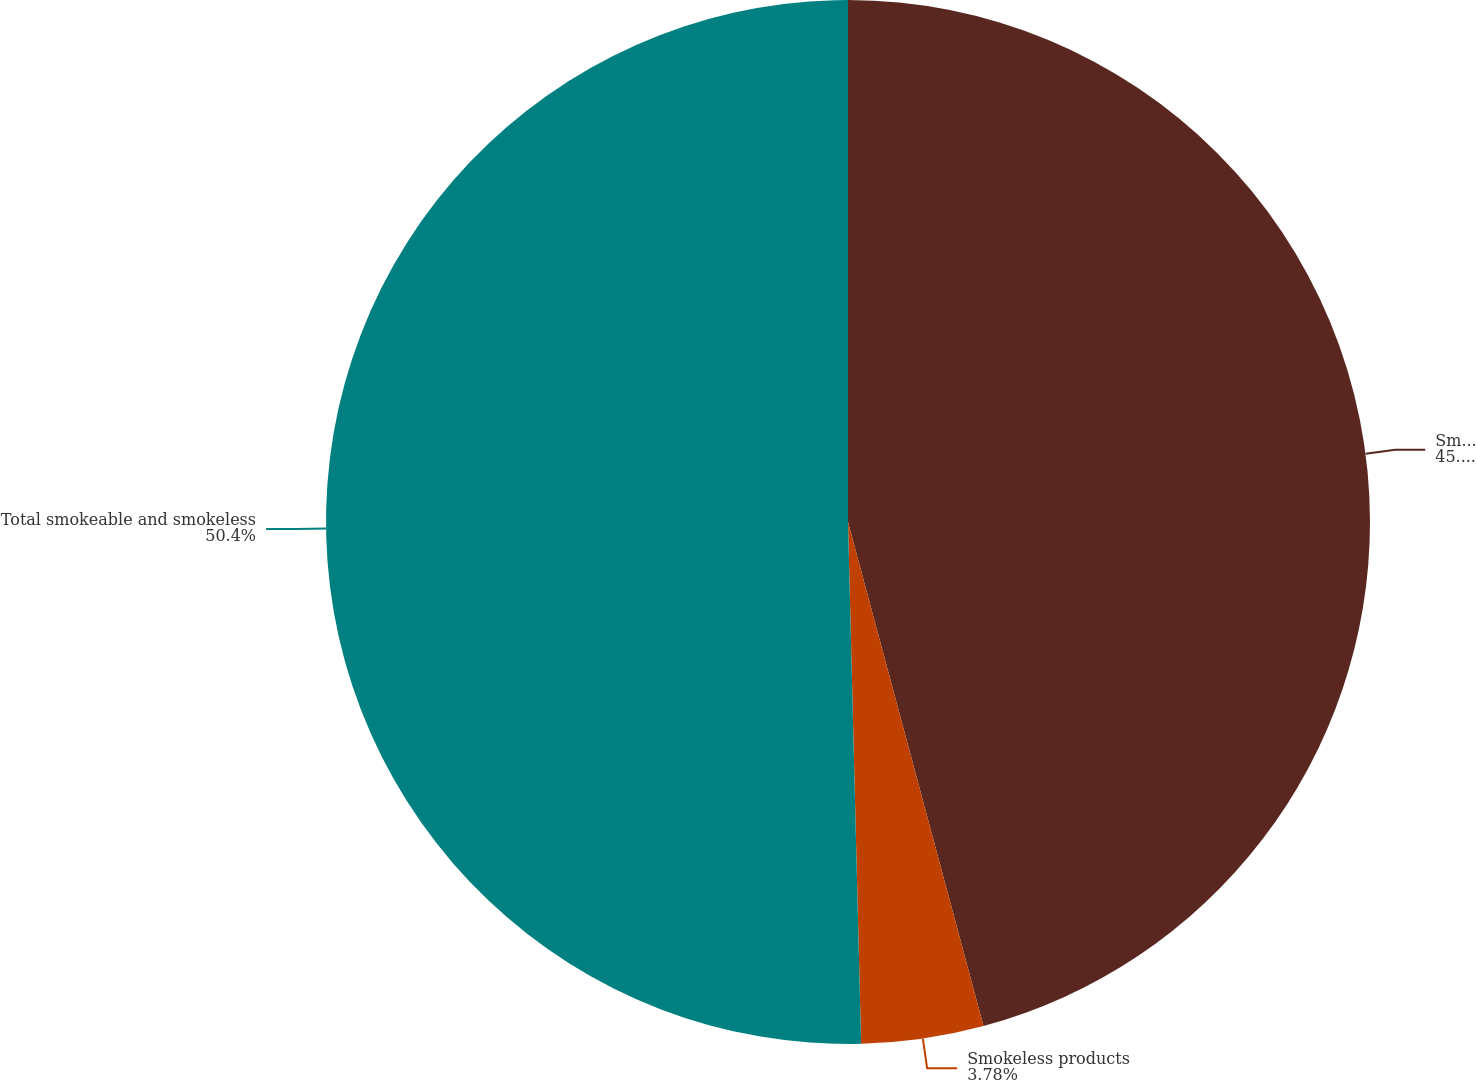Convert chart. <chart><loc_0><loc_0><loc_500><loc_500><pie_chart><fcel>Smokeable products<fcel>Smokeless products<fcel>Total smokeable and smokeless<nl><fcel>45.82%<fcel>3.78%<fcel>50.4%<nl></chart> 